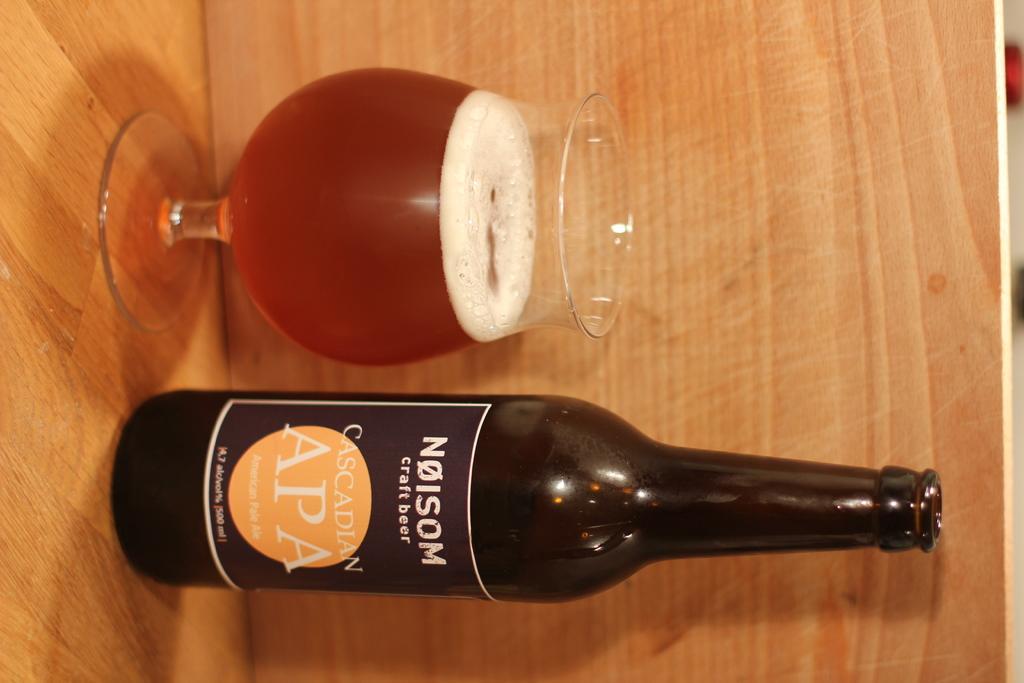Describe this image in one or two sentences. In the image there is a black color bottle and the label of the bottle is also black color and it is written as "NOISE" on the bottle, to its left side there is a glass and there is some drink inside the glass,both of them are placed on a wooden background. 